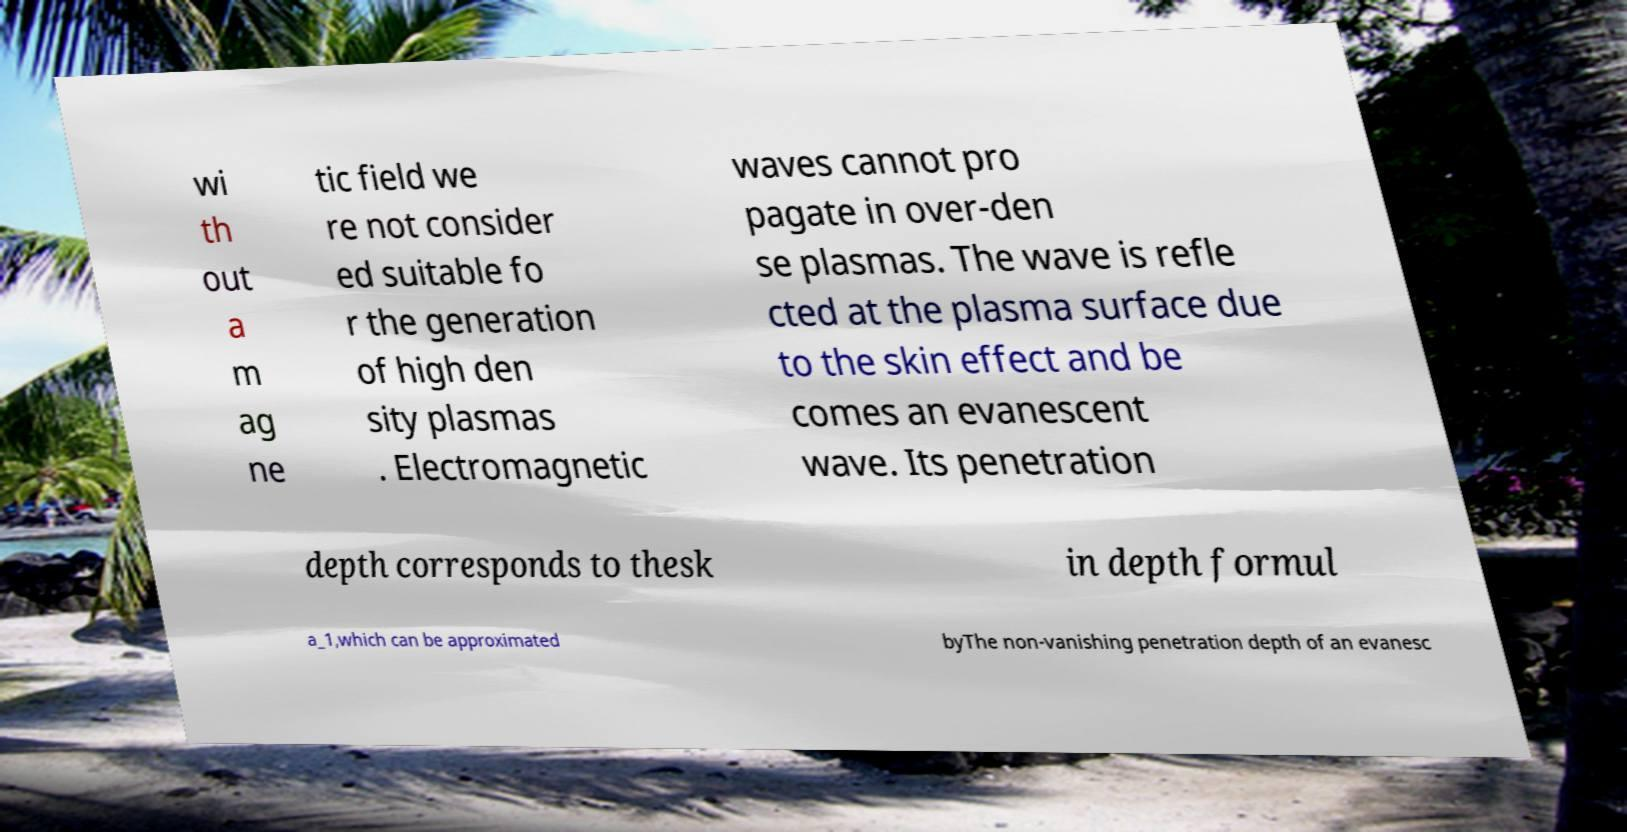Please read and relay the text visible in this image. What does it say? wi th out a m ag ne tic field we re not consider ed suitable fo r the generation of high den sity plasmas . Electromagnetic waves cannot pro pagate in over-den se plasmas. The wave is refle cted at the plasma surface due to the skin effect and be comes an evanescent wave. Its penetration depth corresponds to thesk in depth formul a_1,which can be approximated byThe non-vanishing penetration depth of an evanesc 